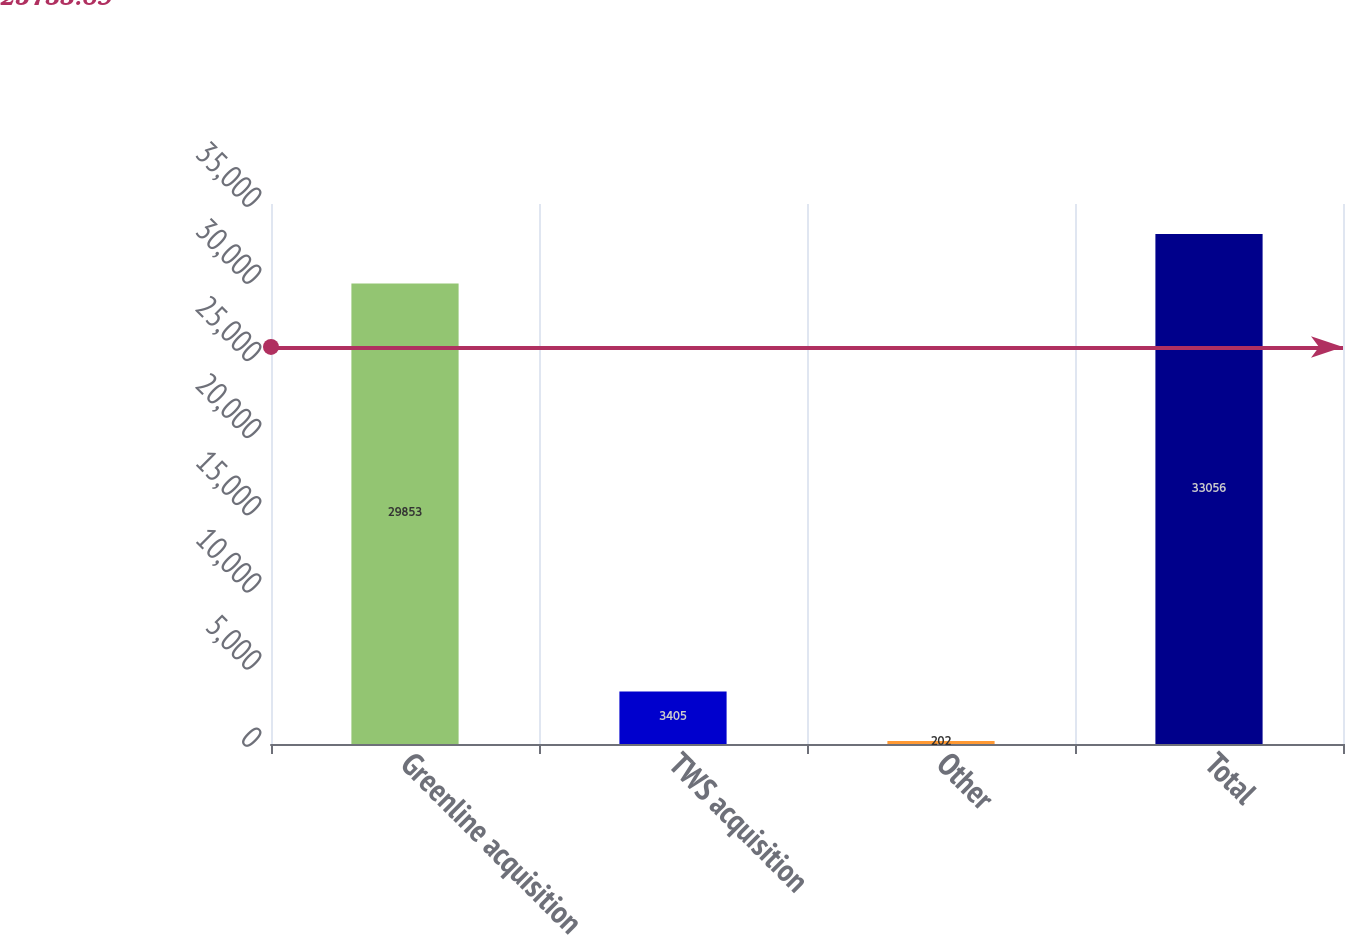Convert chart. <chart><loc_0><loc_0><loc_500><loc_500><bar_chart><fcel>Greenline acquisition<fcel>TWS acquisition<fcel>Other<fcel>Total<nl><fcel>29853<fcel>3405<fcel>202<fcel>33056<nl></chart> 